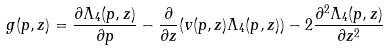<formula> <loc_0><loc_0><loc_500><loc_500>g ( p , z ) = \frac { \partial \Lambda _ { 4 } ( p , z ) } { \partial p } - \frac { \partial } { \partial z } ( v ( p , z ) \Lambda _ { 4 } ( p , z ) ) - 2 \frac { \partial ^ { 2 } \Lambda _ { 4 } ( p , z ) } { \partial z ^ { 2 } }</formula> 